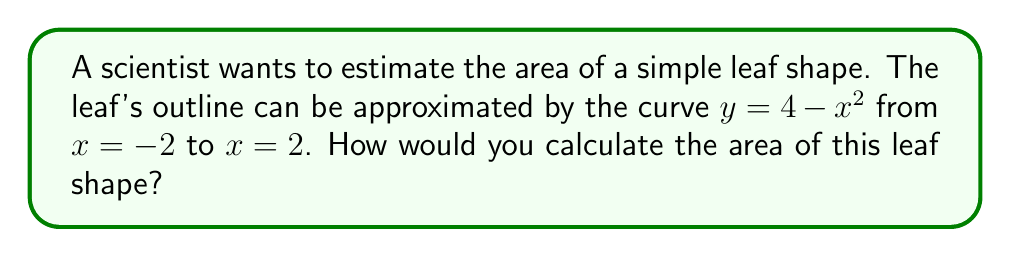Give your solution to this math problem. To calculate the area of the leaf shape, we need to use integration. Here's how we can do it step-by-step:

1. The leaf shape is represented by the area under the curve $y = 4 - x^2$ from $x = -2$ to $x = 2$.

2. To find the area, we need to integrate the function over this interval:

   $$A = \int_{-2}^{2} (4 - x^2) dx$$

3. Let's break down the integral:

   $$A = \int_{-2}^{2} 4 dx - \int_{-2}^{2} x^2 dx$$

4. Integrate each part:
   
   For $\int 4 dx$, the antiderivative is $4x$.
   For $\int x^2 dx$, the antiderivative is $\frac{1}{3}x^3$.

5. Apply the fundamental theorem of calculus:

   $$A = [4x]_{-2}^{2} - [\frac{1}{3}x^3]_{-2}^{2}$$

6. Evaluate the expression:

   $$A = (4 \cdot 2 - 4 \cdot (-2)) - (\frac{1}{3} \cdot 2^3 - \frac{1}{3} \cdot (-2)^3)$$
   $$A = (8 + 8) - (\frac{8}{3} + \frac{8}{3})$$
   $$A = 16 - \frac{16}{3}$$

7. Simplify:

   $$A = \frac{48}{3} - \frac{16}{3} = \frac{32}{3}$$

Therefore, the area of the leaf shape is $\frac{32}{3}$ square units.
Answer: $\frac{32}{3}$ square units 